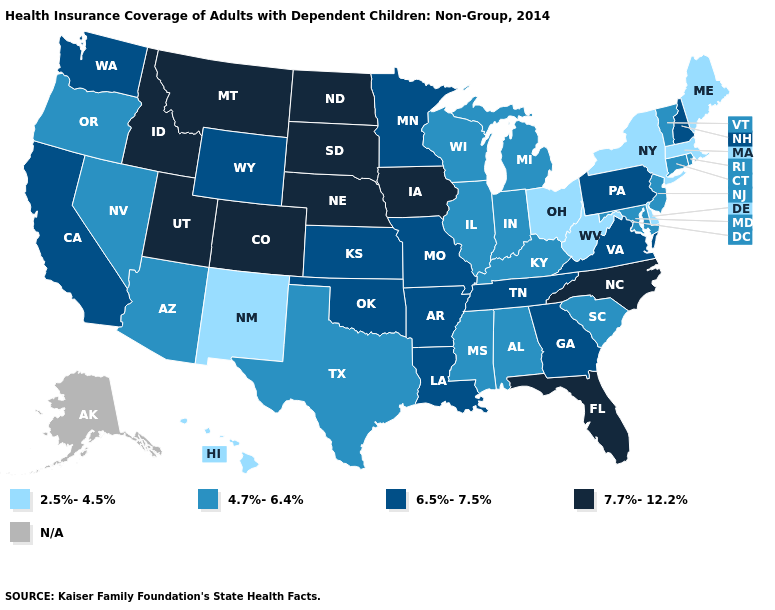Name the states that have a value in the range N/A?
Be succinct. Alaska. What is the highest value in states that border South Dakota?
Give a very brief answer. 7.7%-12.2%. What is the value of New York?
Concise answer only. 2.5%-4.5%. Name the states that have a value in the range N/A?
Answer briefly. Alaska. Does the map have missing data?
Short answer required. Yes. What is the value of Maryland?
Keep it brief. 4.7%-6.4%. Does Kansas have the highest value in the USA?
Concise answer only. No. What is the value of Illinois?
Keep it brief. 4.7%-6.4%. Which states have the lowest value in the MidWest?
Quick response, please. Ohio. Does Idaho have the highest value in the West?
Be succinct. Yes. What is the lowest value in the West?
Quick response, please. 2.5%-4.5%. Does Idaho have the highest value in the USA?
Write a very short answer. Yes. What is the value of North Dakota?
Write a very short answer. 7.7%-12.2%. 